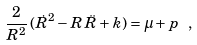<formula> <loc_0><loc_0><loc_500><loc_500>\frac { 2 } { R ^ { 2 } } \, ( \dot { R } ^ { 2 } - R \, \ddot { R } + k ) = \mu + p \ ,</formula> 